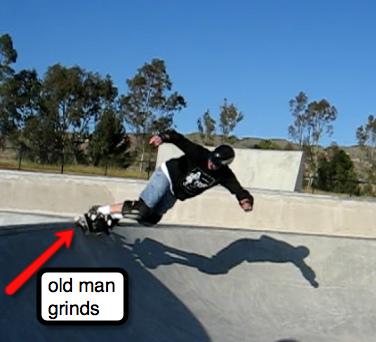Is he rollerblading?
Quick response, please. No. Is he wearing a helmet?
Answer briefly. Yes. Is he wearing jeans?
Write a very short answer. Yes. 